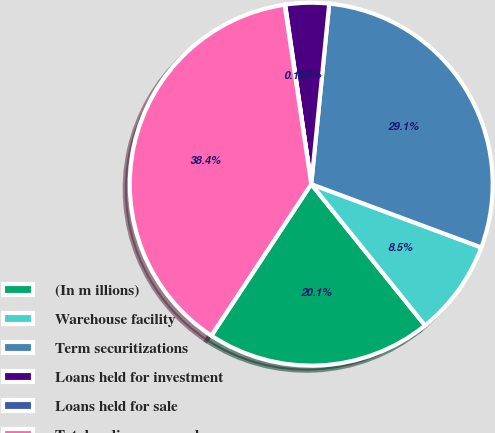Convert chart. <chart><loc_0><loc_0><loc_500><loc_500><pie_chart><fcel>(In m illions)<fcel>Warehouse facility<fcel>Term securitizations<fcel>Loans held for investment<fcel>Loans held for sale<fcel>Total ending managed<nl><fcel>20.07%<fcel>8.54%<fcel>29.09%<fcel>3.88%<fcel>0.05%<fcel>38.37%<nl></chart> 